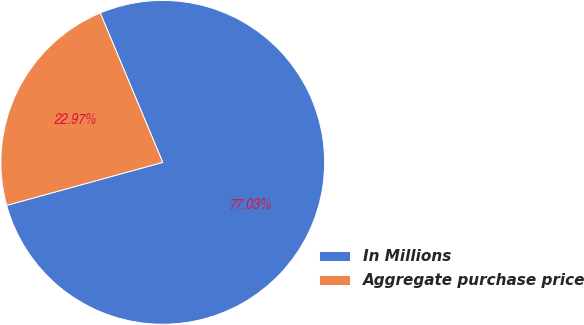Convert chart. <chart><loc_0><loc_0><loc_500><loc_500><pie_chart><fcel>In Millions<fcel>Aggregate purchase price<nl><fcel>77.03%<fcel>22.97%<nl></chart> 